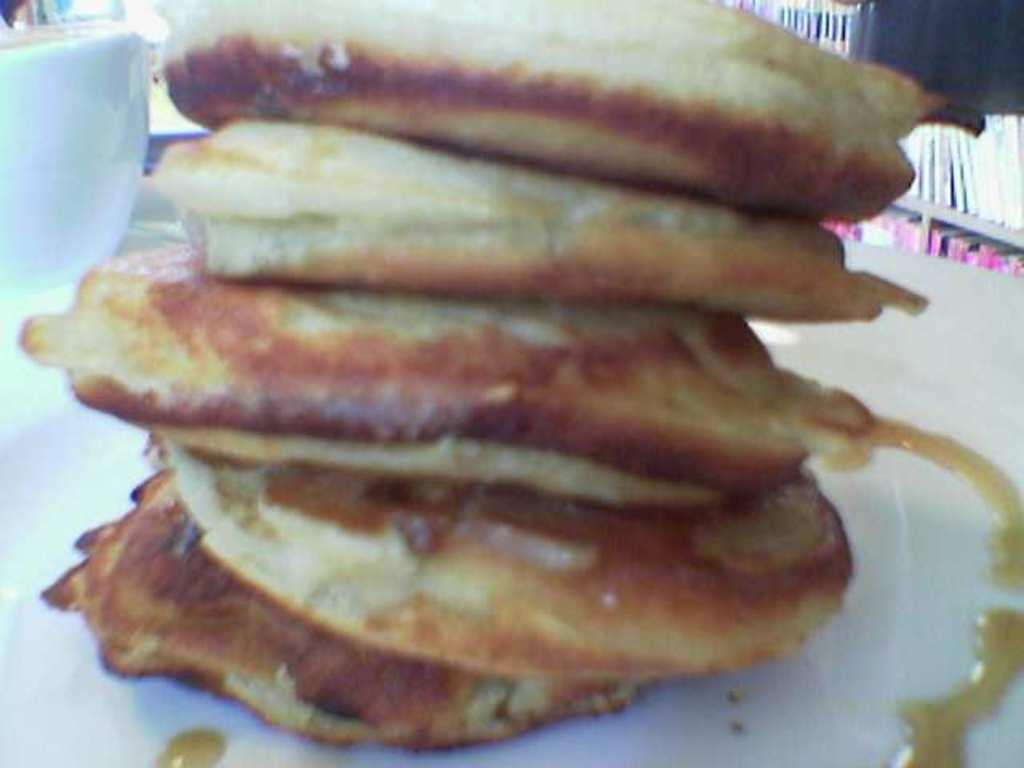What is on the plate in the image? There is a food item on a plate in the image. What can be seen on the table besides the plate? There is a coffee cup on the table in the image. Where are the books located in the image? The books are on a bookshelf in the image. Is there a gun on the desk in the image? There is no desk or gun present in the image. What type of burst can be seen in the image? There is no burst present in the image. 